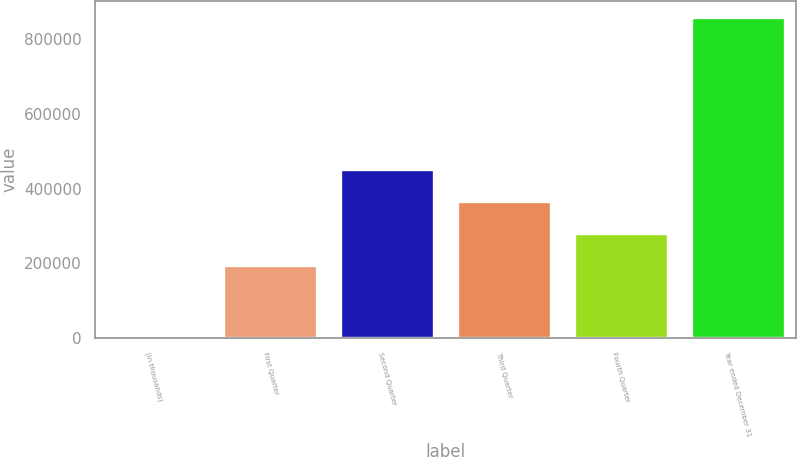<chart> <loc_0><loc_0><loc_500><loc_500><bar_chart><fcel>(in thousands)<fcel>First Quarter<fcel>Second Quarter<fcel>Third Quarter<fcel>Fourth Quarter<fcel>Year ended December 31<nl><fcel>2006<fcel>194187<fcel>451249<fcel>365561<fcel>279874<fcel>858878<nl></chart> 